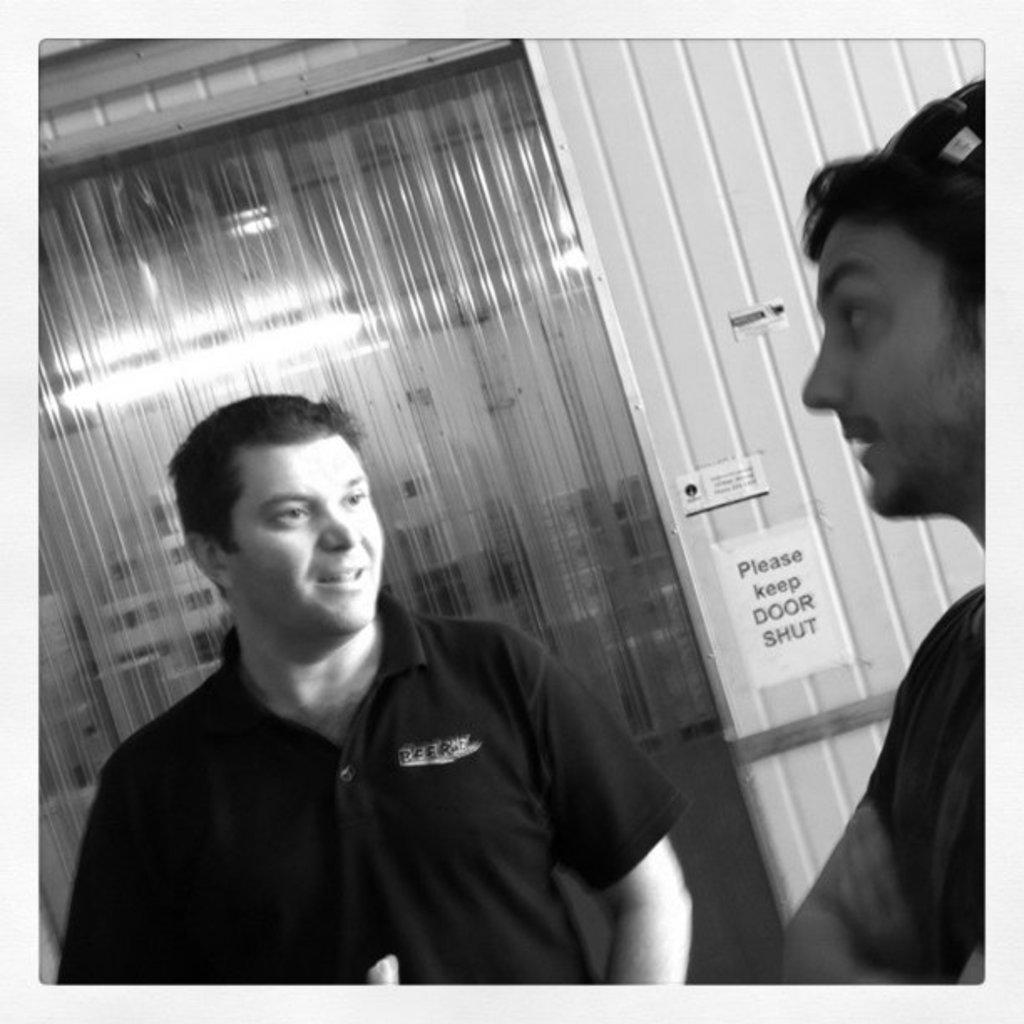What is the color scheme of the image? The image is black and white. How many people are in the image? There are two men standing in the image. What can be seen in the background of the image? There is a wall with posters and a door visible in the background. What type of advertisement is being displayed on the farmer's pump in the image? There is no farmer or pump present in the image; it features two men standing in front of a wall with posters. 